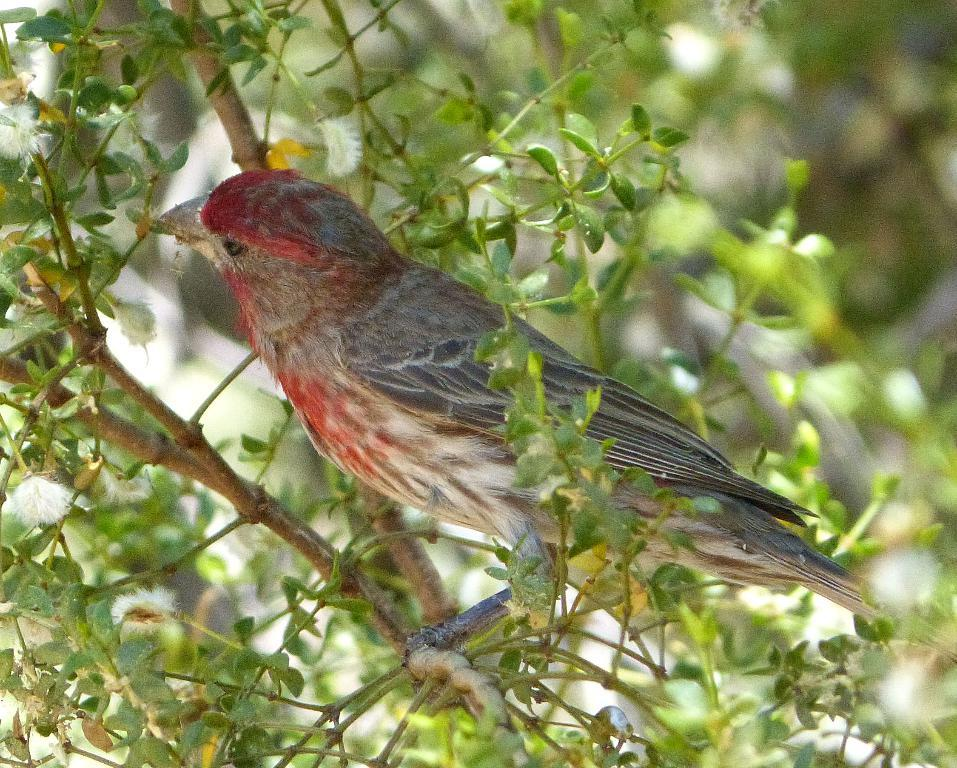What type of animal can be seen in the picture? There is a bird in the picture. What is surrounding the bird in the image? There are stems with leaves around the bird. Can you describe the background of the image? The backdrop of the image is blurred. How many geese are present on top of the bird in the image? There are no geese present in the image, and the bird is not on top of anything. 